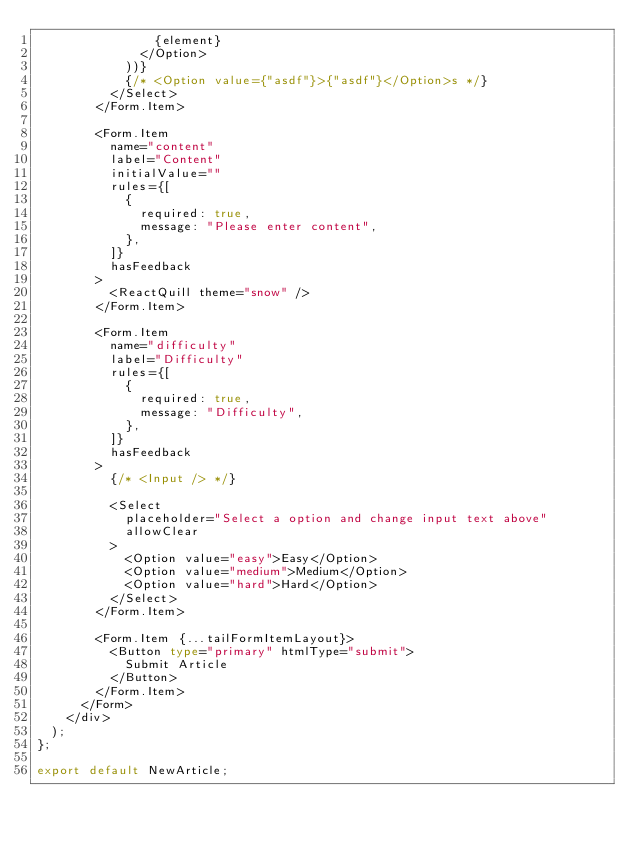Convert code to text. <code><loc_0><loc_0><loc_500><loc_500><_TypeScript_>                {element}
              </Option>
            ))}
            {/* <Option value={"asdf"}>{"asdf"}</Option>s */}
          </Select>
        </Form.Item>

        <Form.Item
          name="content"
          label="Content"
          initialValue=""
          rules={[
            {
              required: true,
              message: "Please enter content",
            },
          ]}
          hasFeedback
        >
          <ReactQuill theme="snow" />
        </Form.Item>

        <Form.Item
          name="difficulty"
          label="Difficulty"
          rules={[
            {
              required: true,
              message: "Difficulty",
            },
          ]}
          hasFeedback
        >
          {/* <Input /> */}

          <Select
            placeholder="Select a option and change input text above"
            allowClear
          >
            <Option value="easy">Easy</Option>
            <Option value="medium">Medium</Option>
            <Option value="hard">Hard</Option>
          </Select>
        </Form.Item>

        <Form.Item {...tailFormItemLayout}>
          <Button type="primary" htmlType="submit">
            Submit Article
          </Button>
        </Form.Item>
      </Form>
    </div>
  );
};

export default NewArticle;
</code> 